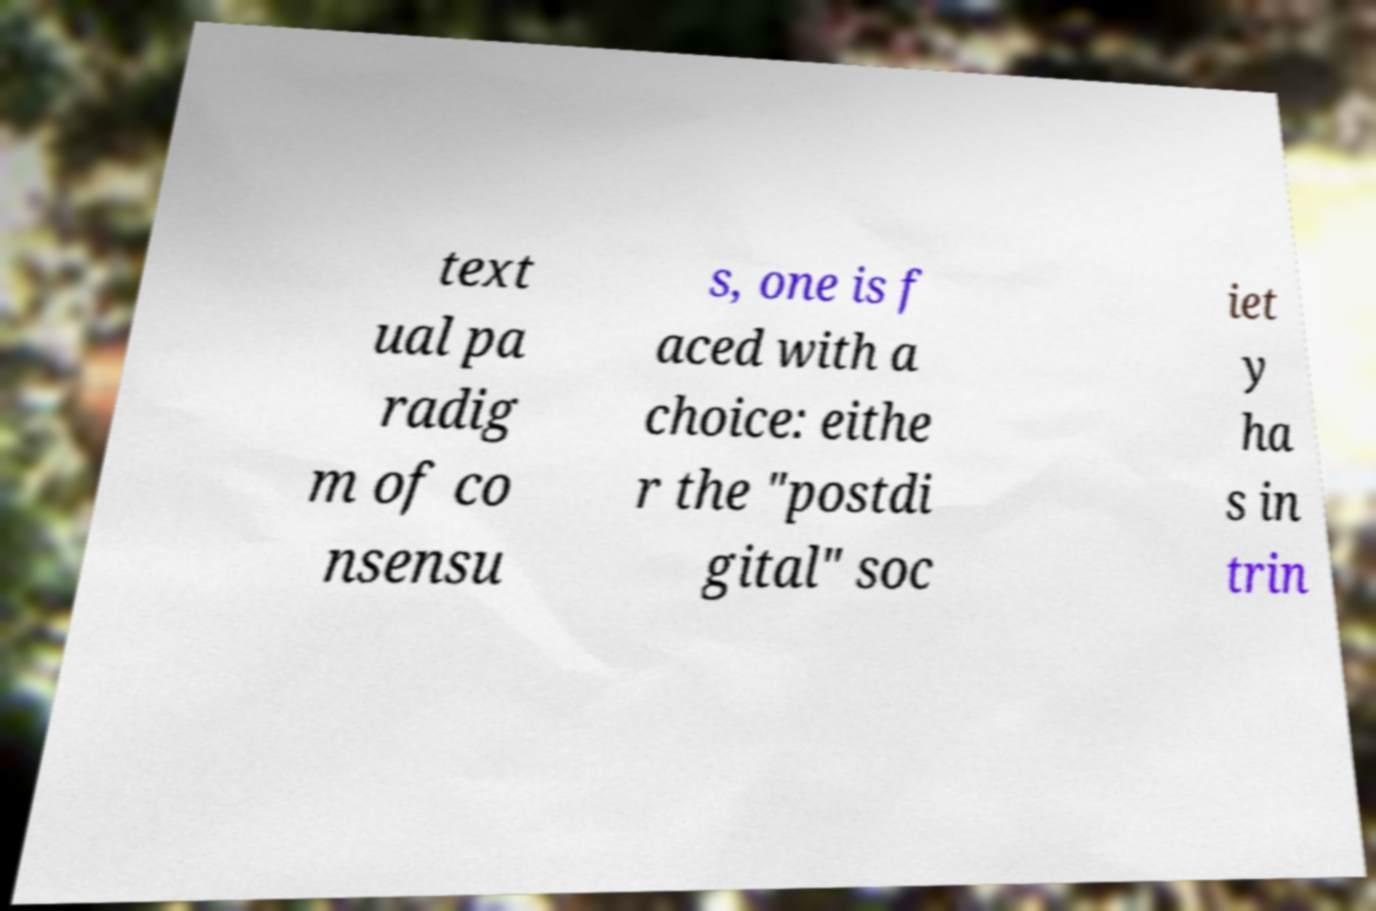Can you read and provide the text displayed in the image?This photo seems to have some interesting text. Can you extract and type it out for me? text ual pa radig m of co nsensu s, one is f aced with a choice: eithe r the "postdi gital" soc iet y ha s in trin 